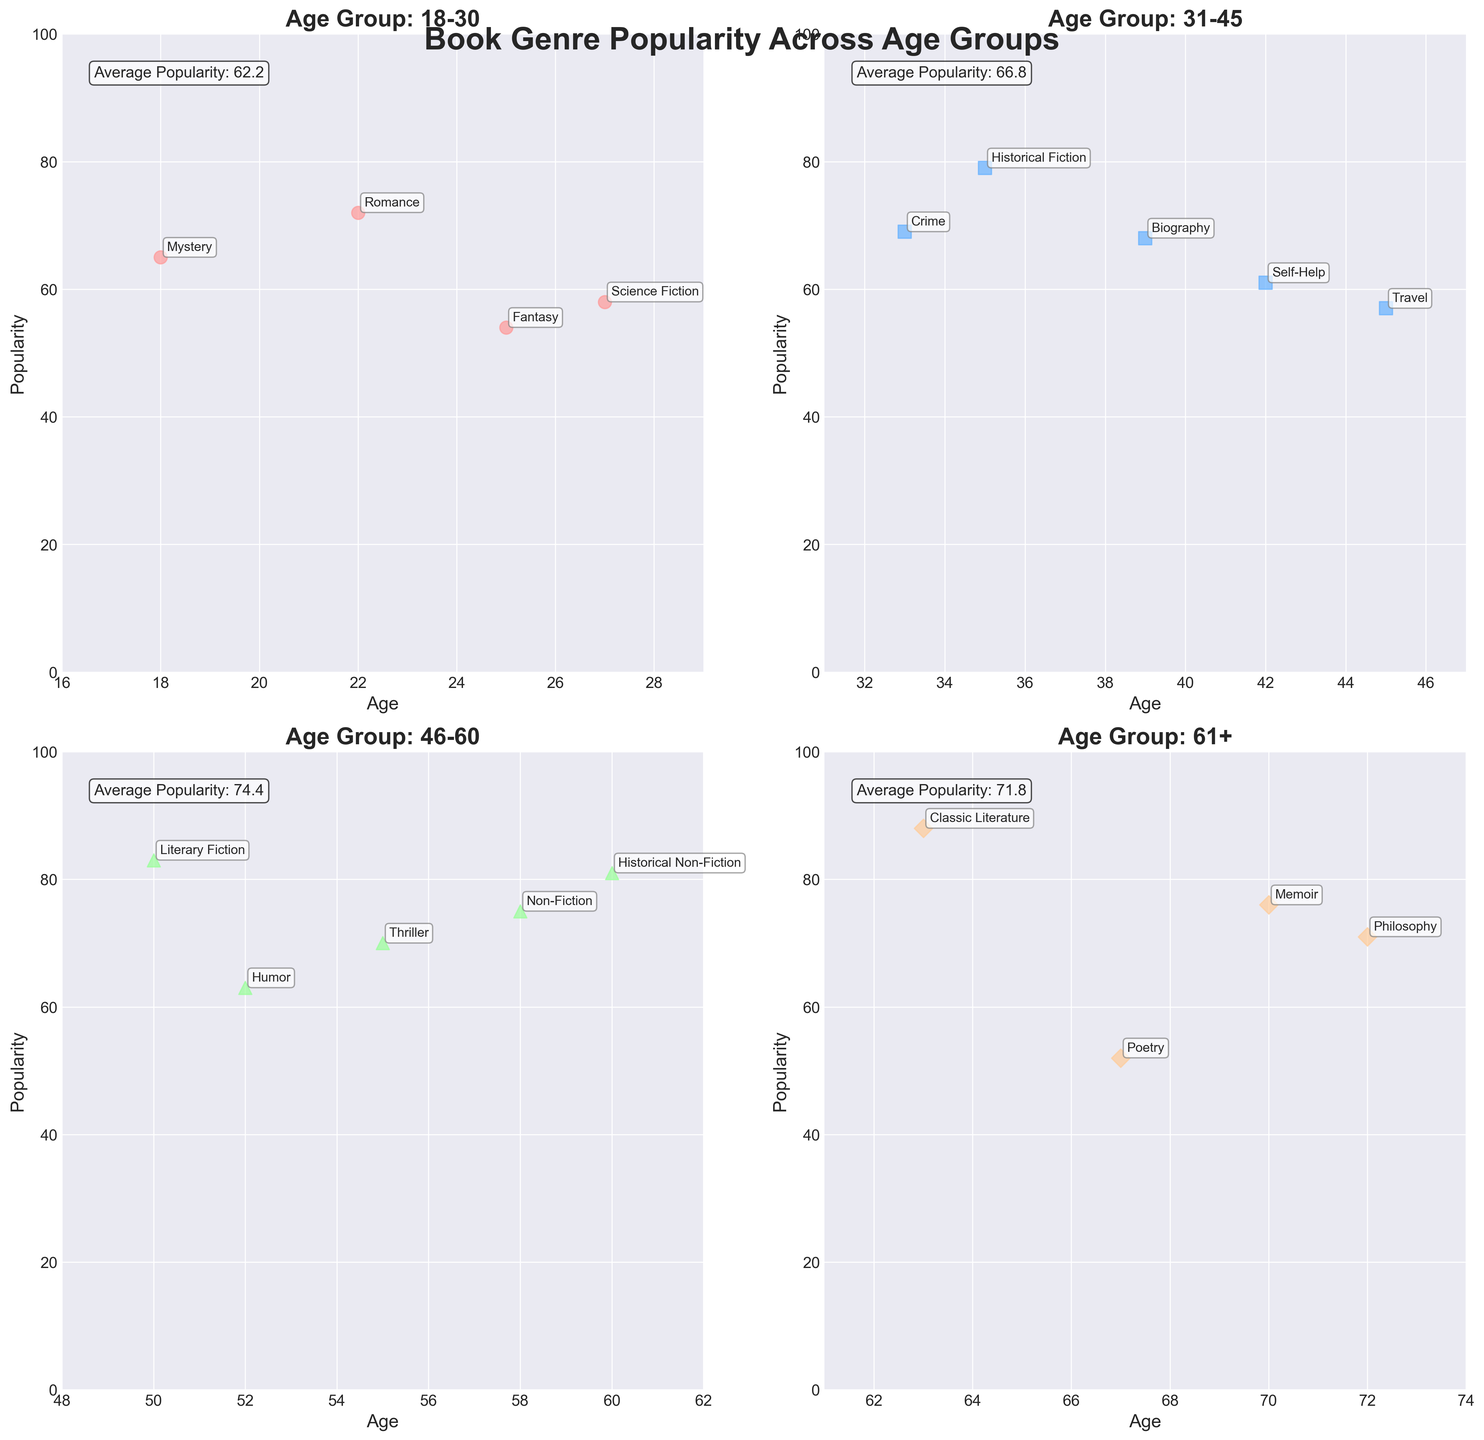What's the title of the figure? The title is usually located at the top of the figure. In this subplot, the title is "Book Genre Popularity Across Age Groups"
Answer: Book Genre Popularity Across Age Groups In the 18-30 age group, which genre has the highest popularity? Look at the subplot labeled "Age Group: 18-30" and find the data point with the highest Popularity value. The genre next to that point is Romance with a popularity score of 72.
Answer: Romance What is the average popularity for books read by people aged 61+? Look at the bottom right subplot labeled "Age Group: 61+". The genres and their popularity scores are Classic Literature (88), Poetry (52), Philosophy (71), and Memoir (76). Calculate the average as (88 + 52 + 71 + 76) / 4 = 71.75.
Answer: 71.75 Which age group has the genre with the highest overall popularity? Find the highest popularity score in each subplot. Compare these scores: 72 for 18-30, 79 for 31-45, 83 for 46-60, and 88 for 61+. The highest score is 88, found in the 61+ age group.
Answer: 61+ How many genres are shown for the age group 31-45? Look at the subplot labeled "Age Group: 31-45" and count the number of annotated genres. The genres shown are Historical Fiction, Biography, Self-Help, Crime, and Travel.
Answer: 5 What's the popularity range for the 46-60 age group? The popularity range is the difference between the highest and lowest popularity values. In the subplot labeled "Age Group: 46-60", the highest score is 83 (Literary Fiction) and the lowest is 57 (Humor). Calculate the range: 83 - 57 = 26.
Answer: 26 Which genre in the 61+ age group has the lowest popularity? Look at the subplot labeled "Age Group: 61+". The genre with the lowest score is Poetry with a popularity of 52.
Answer: Poetry What's the most popular genre for people aged 35? Find the data point corresponding to age 35 in the subplot labeled "Age Group: 31-45". The genre for this data point is Historical Fiction with a popularity of 79.
Answer: Historical Fiction Is the Mystery genre more popular among 18-30 or 31-45 age groups? Locate the data points for the Mystery genre in both subplots ("18-30" and "31-45"). In the 18-30 age group, it has a popularity of 65. For the 31-45 age group, there is no Mystery genre data point noted.
Answer: 18-30 What is the average age of people in the 46-60 age group? List the ages from the "Age Group: 46-60" subplot: 50, 55, 58, 52, 60. Calculate the average as (50 + 55 + 58 + 52 + 60) / 5 = 55.
Answer: 55 